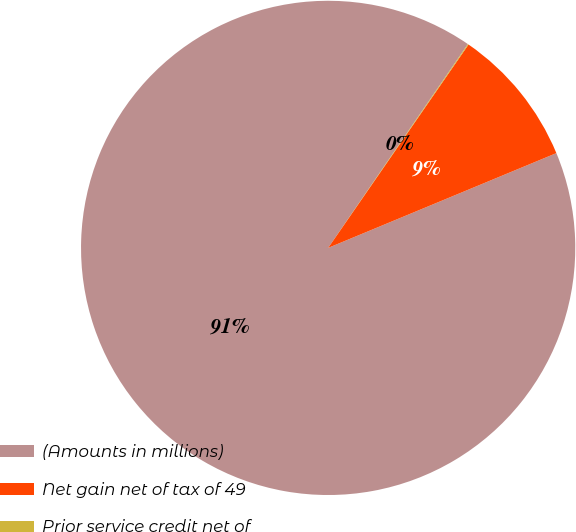<chart> <loc_0><loc_0><loc_500><loc_500><pie_chart><fcel>(Amounts in millions)<fcel>Net gain net of tax of 49<fcel>Prior service credit net of<nl><fcel>90.83%<fcel>9.12%<fcel>0.05%<nl></chart> 